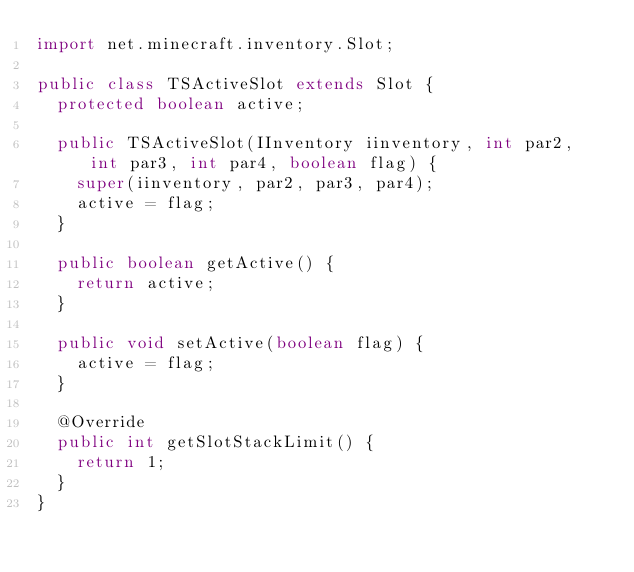Convert code to text. <code><loc_0><loc_0><loc_500><loc_500><_Java_>import net.minecraft.inventory.Slot;

public class TSActiveSlot extends Slot {
	protected boolean active;

	public TSActiveSlot(IInventory iinventory, int par2, int par3, int par4, boolean flag) {
		super(iinventory, par2, par3, par4);
		active = flag;
	}

	public boolean getActive() {
		return active;
	}

	public void setActive(boolean flag) {
		active = flag;
	}

	@Override
	public int getSlotStackLimit() {
		return 1;
	}
}</code> 